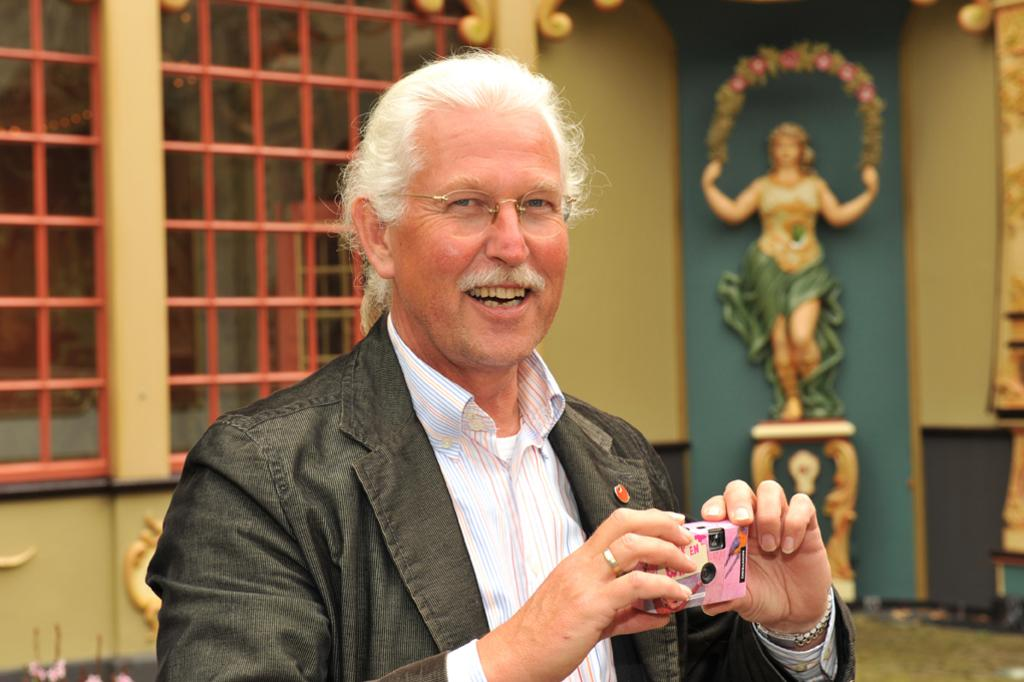What is the main subject of the image? The main subject of the image is a man. What is the man doing in the image? The man is standing in the image. What object is the man holding in his hand? The man is holding a camera in his hand. What is the price of the man's mind in the image? The image does not provide information about the price of the man's mind, as it is not a tangible object that can be priced. 